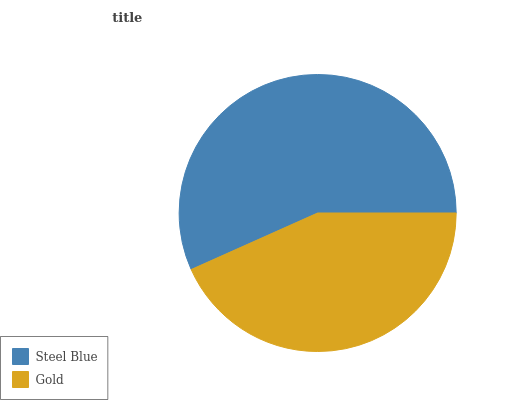Is Gold the minimum?
Answer yes or no. Yes. Is Steel Blue the maximum?
Answer yes or no. Yes. Is Gold the maximum?
Answer yes or no. No. Is Steel Blue greater than Gold?
Answer yes or no. Yes. Is Gold less than Steel Blue?
Answer yes or no. Yes. Is Gold greater than Steel Blue?
Answer yes or no. No. Is Steel Blue less than Gold?
Answer yes or no. No. Is Steel Blue the high median?
Answer yes or no. Yes. Is Gold the low median?
Answer yes or no. Yes. Is Gold the high median?
Answer yes or no. No. Is Steel Blue the low median?
Answer yes or no. No. 